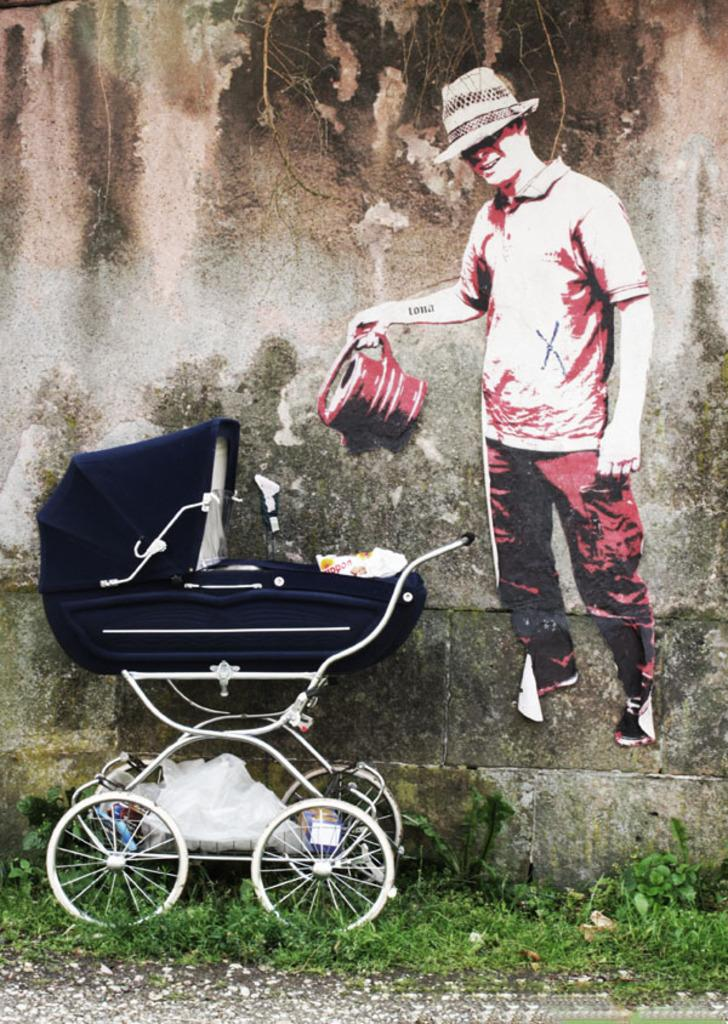What is depicted on the wall poster in the image? There is a wall poster of a man in the image. Where is the wall poster located? The poster is on a wall. What can be seen on the ground on the left side of the image? There is a cradle on the ground on the left side of the image. What type of objects are visible at the bottom of the image? There are stones visible at the bottom of the image. What type of yak can be seen standing next to the cradle in the image? There is no yak present in the image; it only features a wall poster, a wall, a cradle, and stones. What is the purpose of the cork in the image? There is no cork present in the image. 